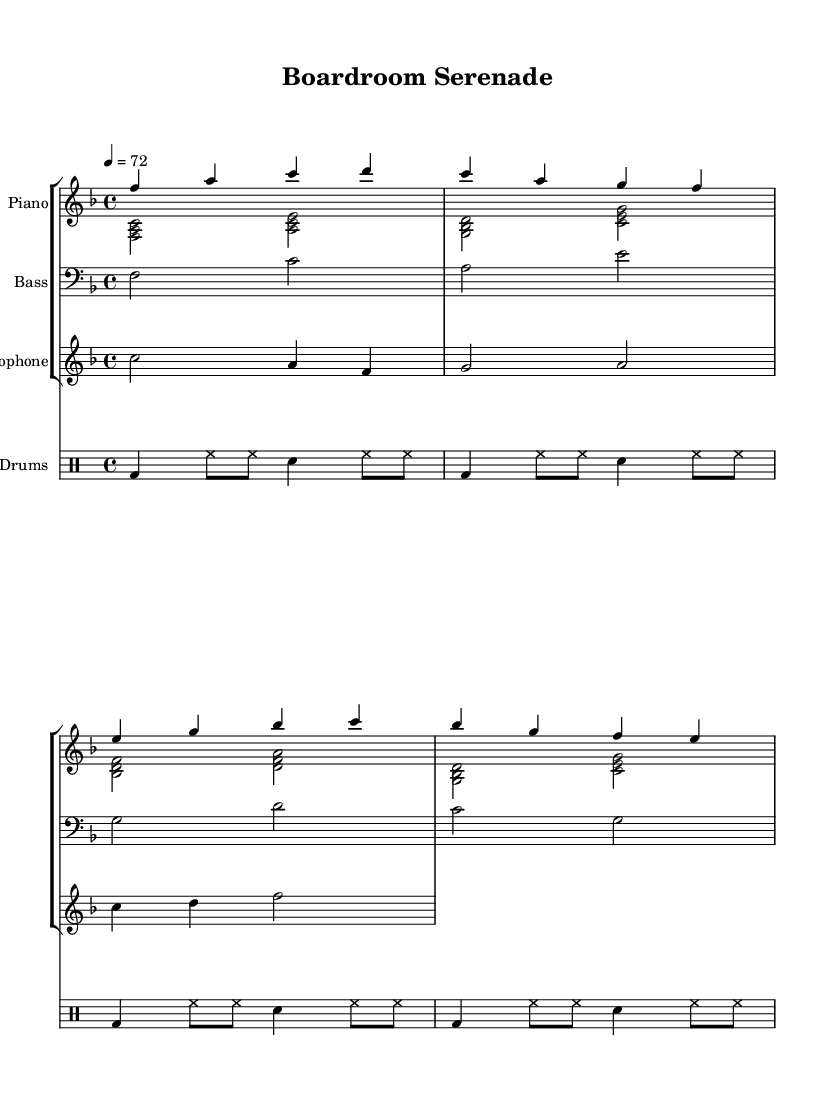What is the key signature of this music? The key signature is F major, which contains one flat, B flat. This can be determined by looking at the key signature markings at the beginning of the score.
Answer: F major What is the time signature of this piece? The time signature is 4/4, indicated by the notation at the beginning of the score. This means there are four beats in a measure, and each quarter note gets one beat.
Answer: 4/4 What is the tempo marking in this score? The tempo marking indicates a pace of 72 beats per minute, as shown by the notation "4 = 72" in the score. This means the quarter note is played at a speed of 72 times per minute.
Answer: 72 How many measures does the piano part consist of? The piano part consists of eight measures, which can be counted by looking at the grouping of the music notes and the bar lines in the right and left-hand staves.
Answer: Eight Which instruments play the harmony in this arrangement? The harmony is primarily provided by the piano and the bass. The piano plays both the right-hand melody and left-hand chords, while the bass outlines the harmonic framework.
Answer: Piano and Bass What type of jazz is this composition intended for? This composition is intended for smooth jazz, characterized by its mellow tones and refined instrumentation, often suitable for corporate or relaxing environments. This can be inferred from both the style of the chords and melody choices typical in smooth jazz.
Answer: Smooth jazz What role does the saxophone play in this arrangement? The saxophone plays a melodic role, providing the main melodic line that complements the harmonic background set by the piano and bass. This is evident from its prominent position in the score and stylistic function typical of jazz ensembles.
Answer: Melodic 